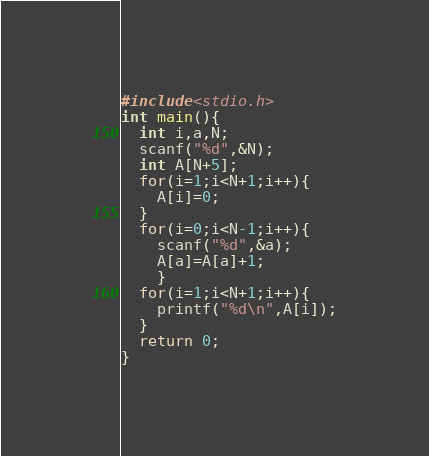Convert code to text. <code><loc_0><loc_0><loc_500><loc_500><_C_>#include<stdio.h>
int main(){
  int i,a,N;
  scanf("%d",&N);
  int A[N+5];
  for(i=1;i<N+1;i++){
    A[i]=0;
  }
  for(i=0;i<N-1;i++){
    scanf("%d",&a);
    A[a]=A[a]+1;
    }
  for(i=1;i<N+1;i++){
    printf("%d\n",A[i]);
  }
  return 0;
}</code> 